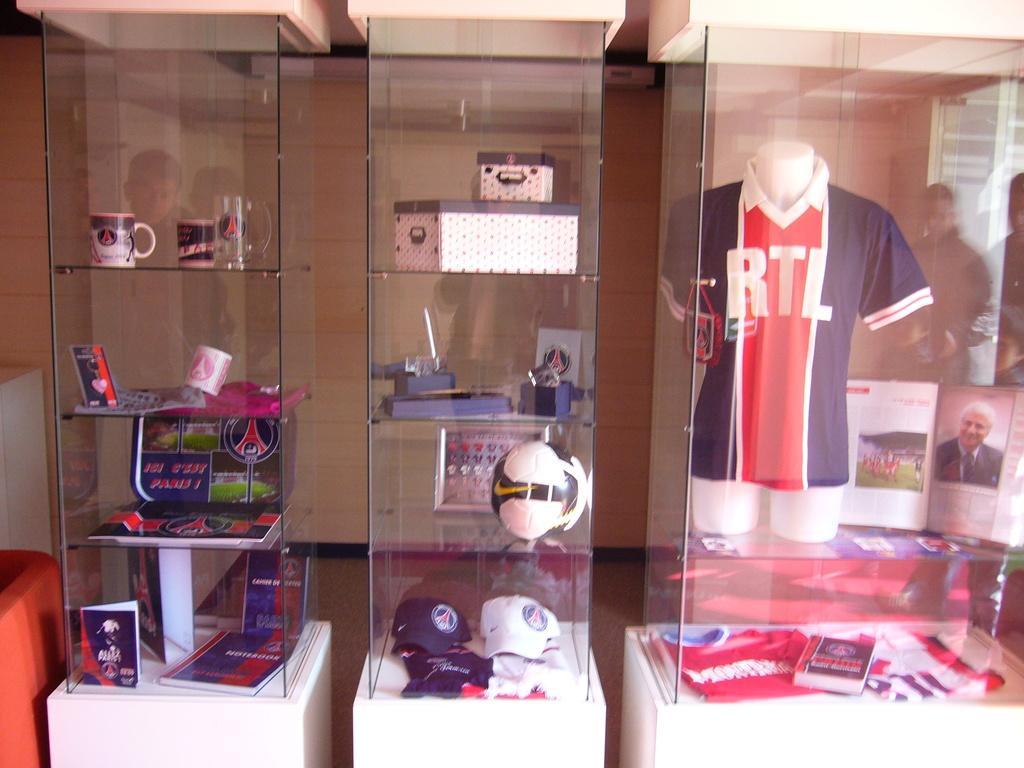Please provide a concise description of this image. In this image we can see a shirt on a mannequin, group of caps, cups, boxes, ball, frames are placed on the racks. In the background, we can see a group of people. 